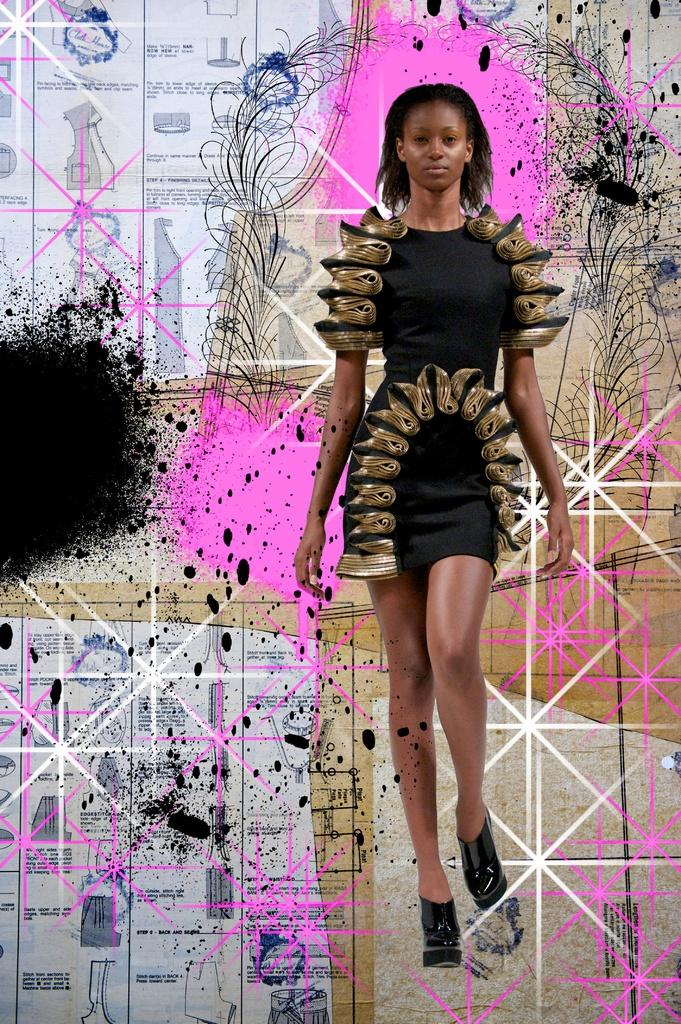Who is the main subject in the image? There is a lady in the image. What is the lady wearing? The lady is wearing a black dress. What can be seen in the background of the image? There is an art piece on the wall in the background of the image. What type of lace can be seen on the dog in the image? There is no dog present in the image, and therefore no lace can be seen on a dog. 